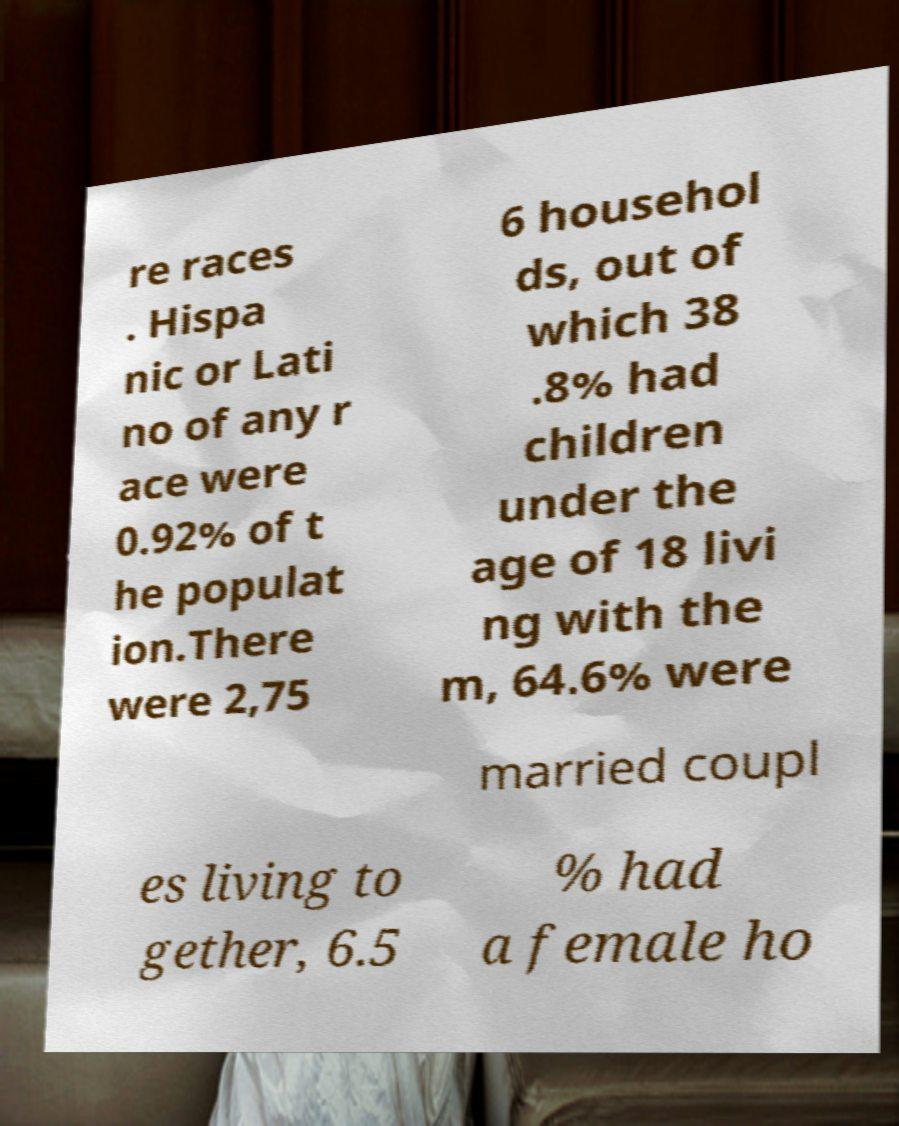Could you extract and type out the text from this image? re races . Hispa nic or Lati no of any r ace were 0.92% of t he populat ion.There were 2,75 6 househol ds, out of which 38 .8% had children under the age of 18 livi ng with the m, 64.6% were married coupl es living to gether, 6.5 % had a female ho 